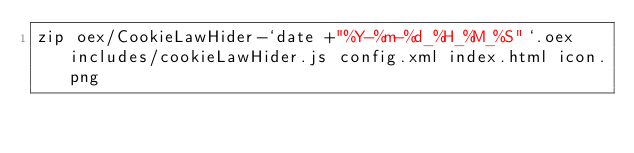<code> <loc_0><loc_0><loc_500><loc_500><_Bash_>zip oex/CookieLawHider-`date +"%Y-%m-%d_%H_%M_%S"`.oex includes/cookieLawHider.js config.xml index.html icon.png
</code> 